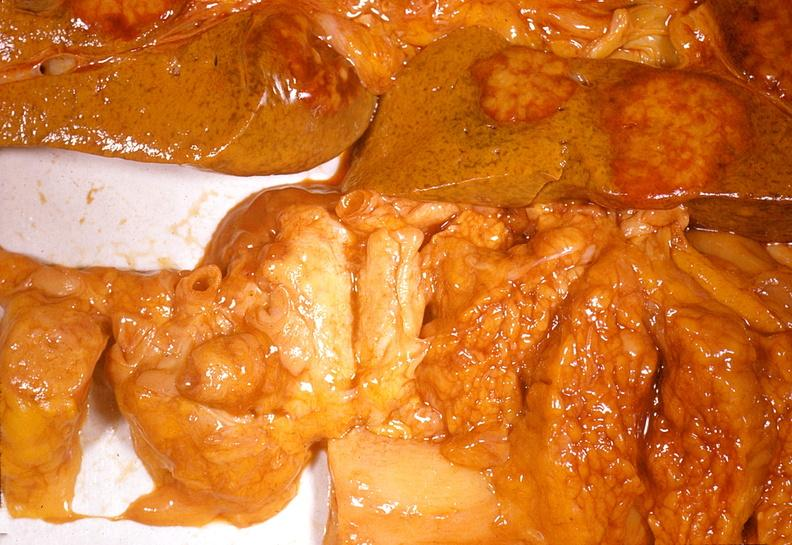does side show adenocarcinoma, body of pancreas?
Answer the question using a single word or phrase. No 